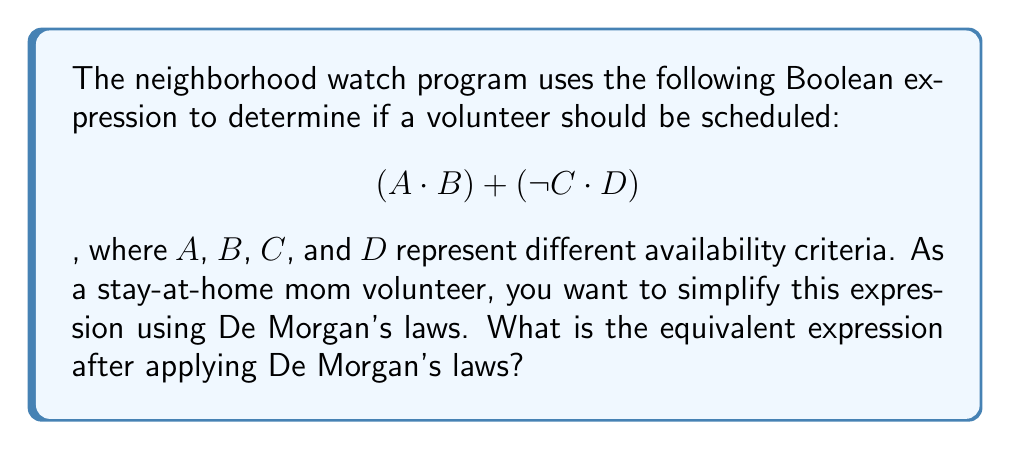Could you help me with this problem? Let's apply De Morgan's laws to simplify the expression step-by-step:

1) The original expression is: $$(A \cdot B) + (\neg C \cdot D)$$

2) We can apply De Morgan's first law to the negation of this expression:
   $$\neg((A \cdot B) + (\neg C \cdot D))$$

3) De Morgan's first law states that the negation of a sum is the product of the negations:
   $$\neg(A \cdot B) \cdot \neg(\neg C \cdot D)$$

4) Now we can apply De Morgan's second law to each part:
   $$((\neg A + \neg B) \cdot (C + \neg D))$$

5) This expression is equivalent to the original one when negated:
   $$\neg((\neg A + \neg B) \cdot (C + \neg D))$$

6) Applying De Morgan's first law again:
   $$(\neg(\neg A + \neg B) + \neg(C + \neg D))$$

7) Apply De Morgan's second law to each part:
   $$((\neg \neg A \cdot \neg \neg B) + (\neg C \cdot \neg \neg D))$$

8) Simplify double negations:
   $$((A \cdot B) + (\neg C \cdot D))$$

This is the same as the original expression, proving that applying De Morgan's laws twice returns the original form.
Answer: $$(A \cdot B) + (\neg C \cdot D)$$ 